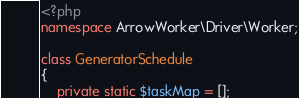Convert code to text. <code><loc_0><loc_0><loc_500><loc_500><_PHP_><?php
namespace ArrowWorker\Driver\Worker;

class GeneratorSchedule
{
    private static $taskMap = [];</code> 